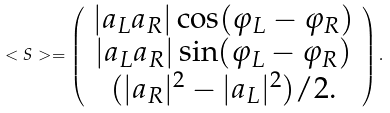Convert formula to latex. <formula><loc_0><loc_0><loc_500><loc_500>< { S } > = \left ( \begin{array} { c } | a _ { L } a _ { R } | \cos ( \varphi _ { L } - \varphi _ { R } ) \\ | a _ { L } a _ { R } | \sin ( \varphi _ { L } - \varphi _ { R } ) \\ ( | a _ { R } | ^ { 2 } - | a _ { L } | ^ { 2 } ) / 2 . \end{array} \right ) .</formula> 